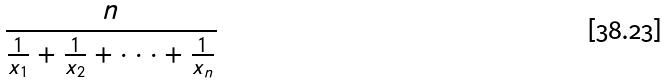<formula> <loc_0><loc_0><loc_500><loc_500>\frac { n } { \frac { 1 } { x _ { 1 } } + \frac { 1 } { x _ { 2 } } + \cdot \cdot \cdot + \frac { 1 } { x _ { n } } }</formula> 